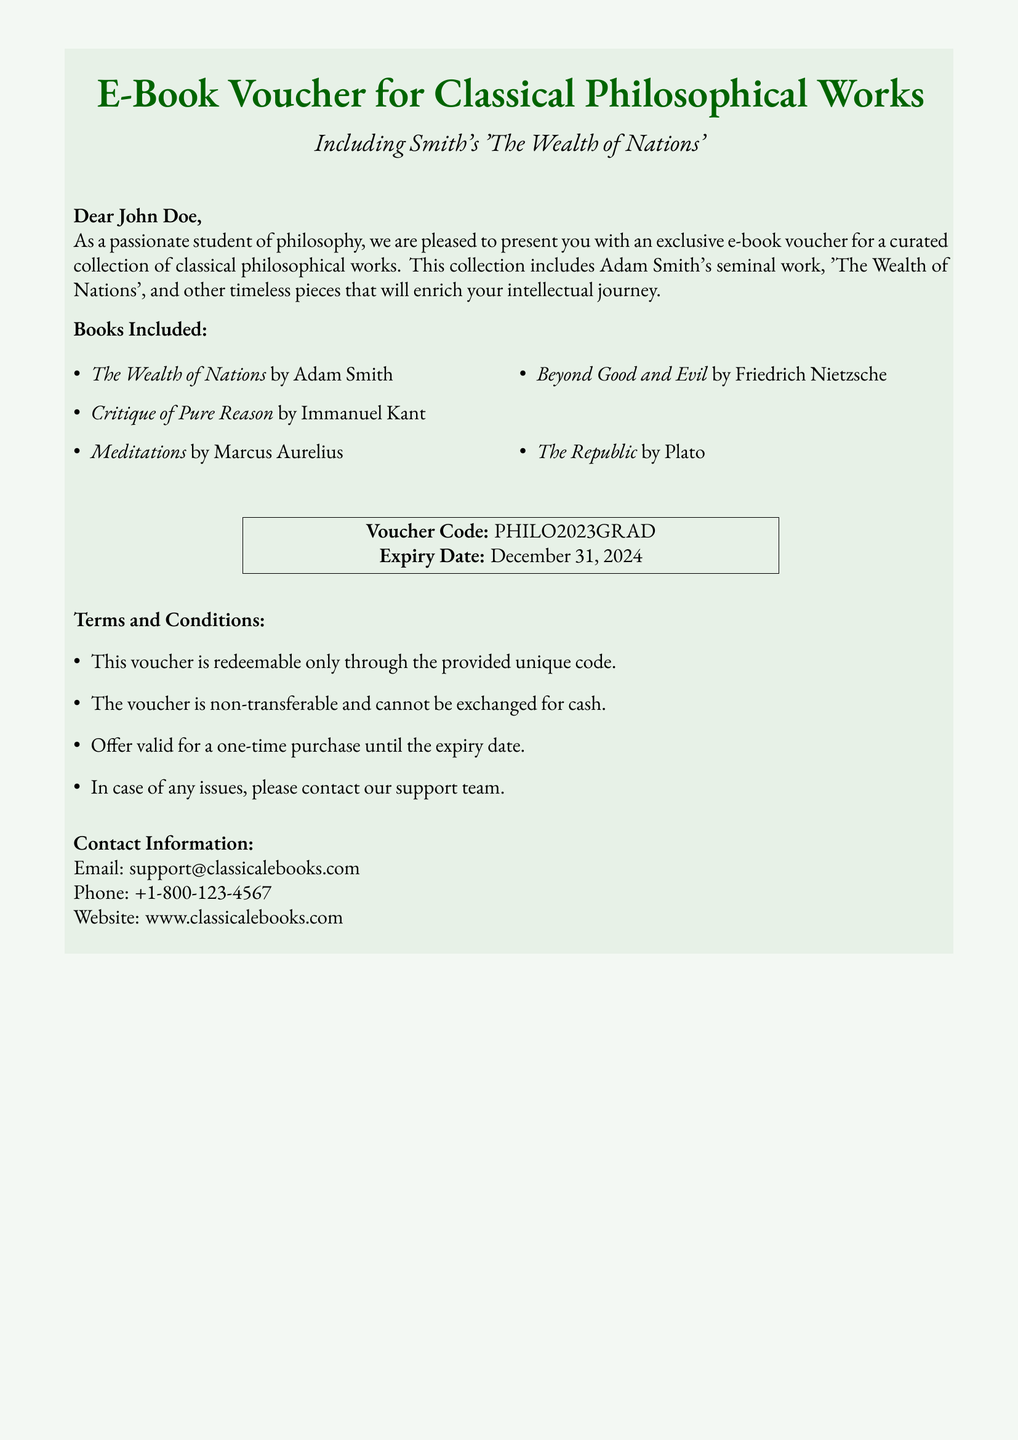What is the title of the e-book collection? The title of the e-book collection is specified in the document as "E-Book Voucher for Classical Philosophical Works".
Answer: E-Book Voucher for Classical Philosophical Works Who is the author of 'The Wealth of Nations'? The document lists Adam Smith as the author of 'The Wealth of Nations'.
Answer: Adam Smith What is the voucher code? The document provides the specific code to redeem the voucher, which is highlighted.
Answer: PHILO2023GRAD What is the expiry date of the voucher? The document states the expiry date of the voucher clearly as December 31, 2024.
Answer: December 31, 2024 Which work by Plato is included in the collection? The document mentions 'The Republic' as one of the works included in the collection.
Answer: The Republic How many books are listed in the voucher? The document enumerates five different books included, and this can be counted directly from the list.
Answer: Five Is the voucher transferable? The document specifies in the terms and conditions that the voucher is non-transferable.
Answer: Non-transferable What type of document is this? The document is presented as a gift voucher specifically for e-books.
Answer: Gift voucher 